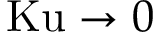<formula> <loc_0><loc_0><loc_500><loc_500>K u \to 0</formula> 